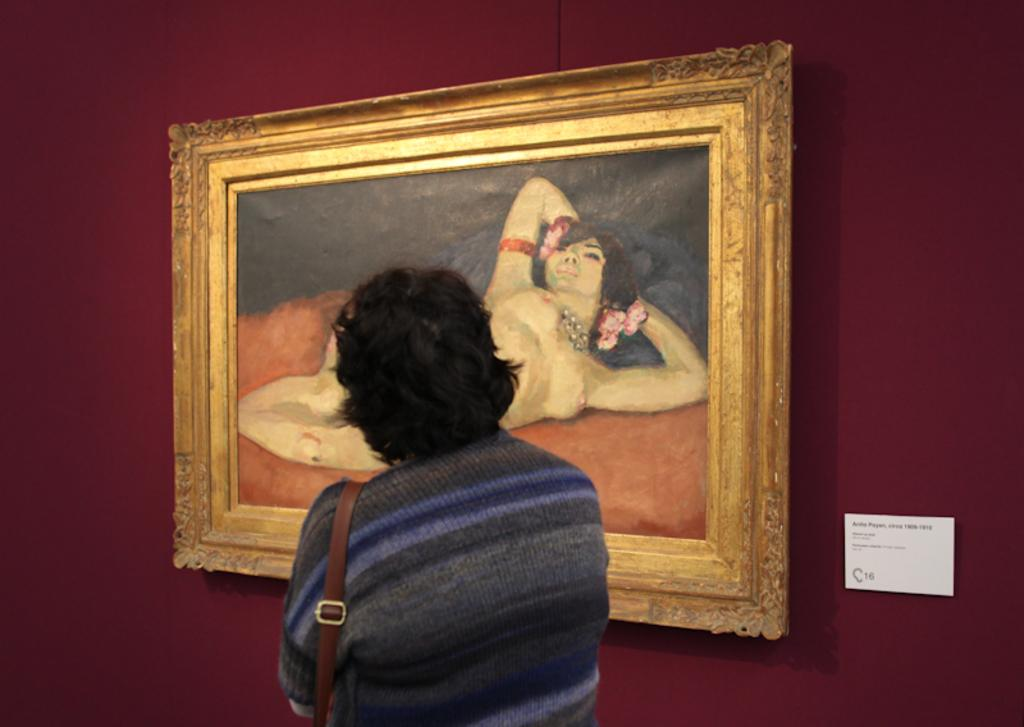Who or what is the main subject in the image? There is a person in the image. What is the person wearing in the image? The person is wearing a sling bag. What can be seen in the background of the image? There is a board and a painting with a frame on the wall in the background. What is the belief system of the arch in the image? There is no arch present in the image, so it is not possible to determine its belief system. 